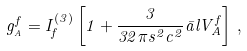Convert formula to latex. <formula><loc_0><loc_0><loc_500><loc_500>g _ { _ { A } } ^ { f } = I _ { f } ^ { ( 3 ) } \left [ 1 + \frac { 3 } { 3 2 \pi s ^ { 2 } c ^ { 2 } } \bar { a } l V _ { A } ^ { f } \right ] \, ,</formula> 